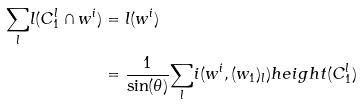<formula> <loc_0><loc_0><loc_500><loc_500>\underset { l } \sum l ( C _ { 1 } ^ { l } \cap w ^ { i } ) & = l ( w ^ { i } ) \\ & = \frac { 1 } { \sin ( \theta ) } \underset { l } \sum i ( w ^ { i } , ( w _ { 1 } ) _ { l } ) h e i g h t ( C _ { 1 } ^ { l } )</formula> 